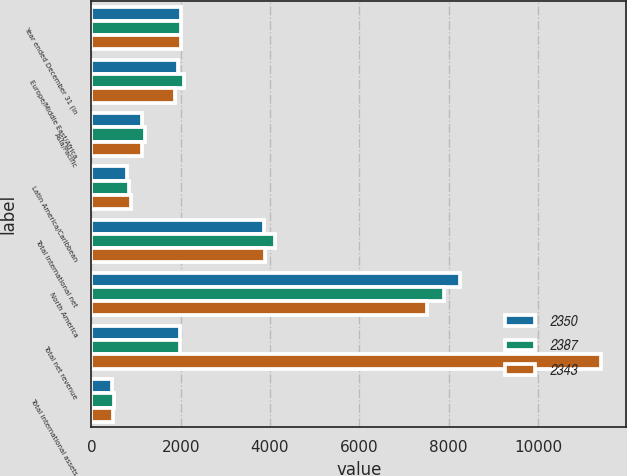<chart> <loc_0><loc_0><loc_500><loc_500><stacked_bar_chart><ecel><fcel>Year ended December 31 (in<fcel>Europe/Middle East/Africa<fcel>Asia/Pacific<fcel>Latin America/Caribbean<fcel>Total international net<fcel>North America<fcel>Total net revenue<fcel>Total international assets<nl><fcel>2350<fcel>2015<fcel>1946<fcel>1130<fcel>795<fcel>3871<fcel>8248<fcel>1979.5<fcel>470<nl><fcel>2387<fcel>2014<fcel>2080<fcel>1199<fcel>841<fcel>4120<fcel>7908<fcel>1979.5<fcel>501<nl><fcel>2343<fcel>2013<fcel>1881<fcel>1133<fcel>879<fcel>3893<fcel>7512<fcel>11405<fcel>484<nl></chart> 